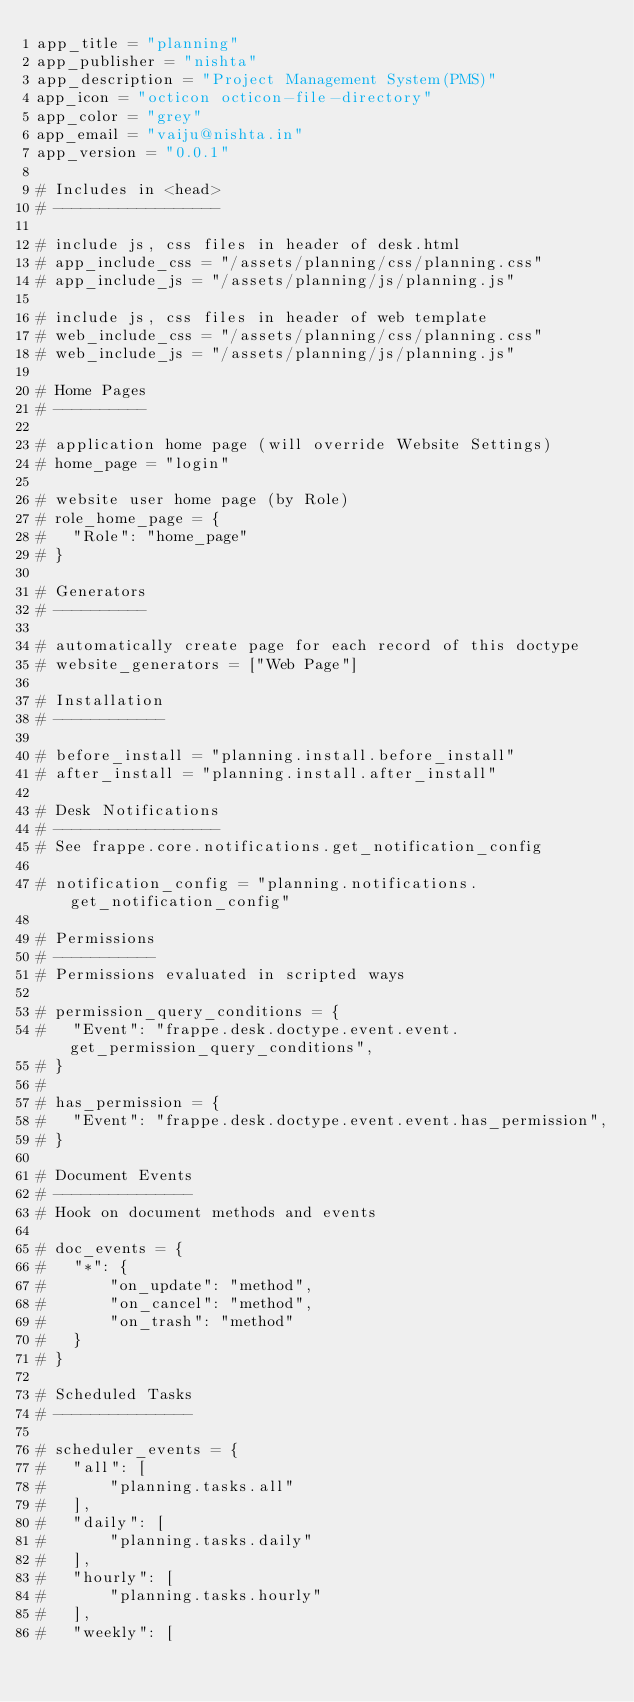<code> <loc_0><loc_0><loc_500><loc_500><_Python_>app_title = "planning"
app_publisher = "nishta"
app_description = "Project Management System(PMS)"
app_icon = "octicon octicon-file-directory"
app_color = "grey"
app_email = "vaiju@nishta.in"
app_version = "0.0.1"

# Includes in <head>
# ------------------

# include js, css files in header of desk.html
# app_include_css = "/assets/planning/css/planning.css"
# app_include_js = "/assets/planning/js/planning.js"

# include js, css files in header of web template
# web_include_css = "/assets/planning/css/planning.css"
# web_include_js = "/assets/planning/js/planning.js"

# Home Pages
# ----------

# application home page (will override Website Settings)
# home_page = "login"

# website user home page (by Role)
# role_home_page = {
#	"Role": "home_page"
# }

# Generators
# ----------

# automatically create page for each record of this doctype
# website_generators = ["Web Page"]

# Installation
# ------------

# before_install = "planning.install.before_install"
# after_install = "planning.install.after_install"

# Desk Notifications
# ------------------
# See frappe.core.notifications.get_notification_config

# notification_config = "planning.notifications.get_notification_config"

# Permissions
# -----------
# Permissions evaluated in scripted ways

# permission_query_conditions = {
# 	"Event": "frappe.desk.doctype.event.event.get_permission_query_conditions",
# }
#
# has_permission = {
# 	"Event": "frappe.desk.doctype.event.event.has_permission",
# }

# Document Events
# ---------------
# Hook on document methods and events

# doc_events = {
# 	"*": {
# 		"on_update": "method",
# 		"on_cancel": "method",
# 		"on_trash": "method"
#	}
# }

# Scheduled Tasks
# ---------------

# scheduler_events = {
# 	"all": [
# 		"planning.tasks.all"
# 	],
# 	"daily": [
# 		"planning.tasks.daily"
# 	],
# 	"hourly": [
# 		"planning.tasks.hourly"
# 	],
# 	"weekly": [</code> 